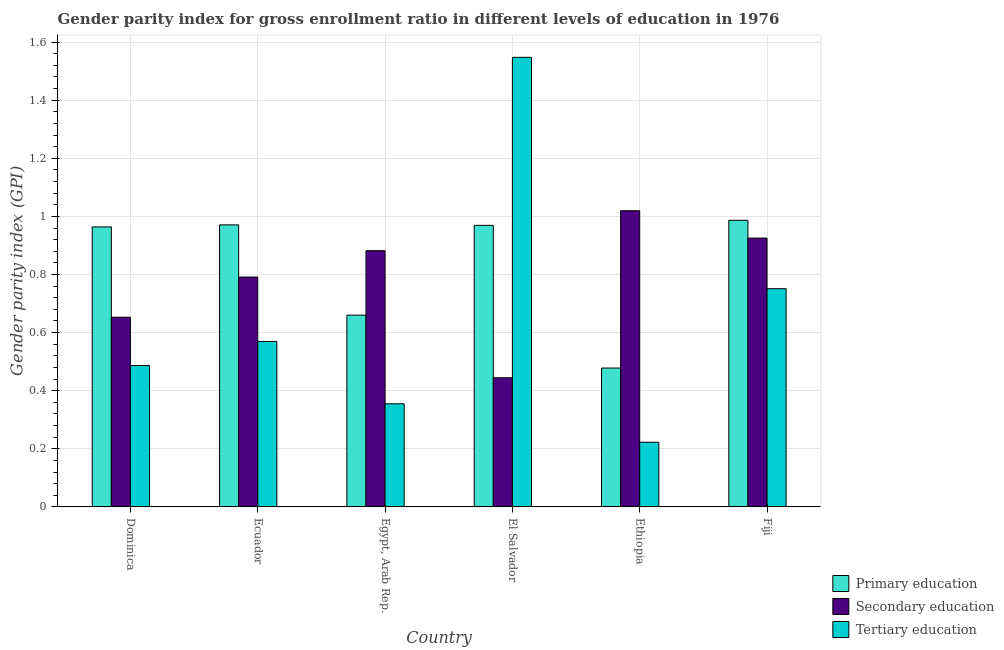How many groups of bars are there?
Ensure brevity in your answer.  6. Are the number of bars per tick equal to the number of legend labels?
Offer a very short reply. Yes. Are the number of bars on each tick of the X-axis equal?
Offer a very short reply. Yes. How many bars are there on the 2nd tick from the left?
Keep it short and to the point. 3. How many bars are there on the 5th tick from the right?
Provide a succinct answer. 3. What is the label of the 6th group of bars from the left?
Your answer should be very brief. Fiji. In how many cases, is the number of bars for a given country not equal to the number of legend labels?
Provide a short and direct response. 0. What is the gender parity index in primary education in Ethiopia?
Give a very brief answer. 0.48. Across all countries, what is the maximum gender parity index in primary education?
Ensure brevity in your answer.  0.99. Across all countries, what is the minimum gender parity index in secondary education?
Make the answer very short. 0.44. In which country was the gender parity index in tertiary education maximum?
Your answer should be very brief. El Salvador. In which country was the gender parity index in primary education minimum?
Your answer should be very brief. Ethiopia. What is the total gender parity index in tertiary education in the graph?
Give a very brief answer. 3.93. What is the difference between the gender parity index in tertiary education in Ecuador and that in El Salvador?
Ensure brevity in your answer.  -0.98. What is the difference between the gender parity index in secondary education in Egypt, Arab Rep. and the gender parity index in tertiary education in Ethiopia?
Your answer should be compact. 0.66. What is the average gender parity index in tertiary education per country?
Offer a very short reply. 0.66. What is the difference between the gender parity index in primary education and gender parity index in tertiary education in Fiji?
Offer a very short reply. 0.24. In how many countries, is the gender parity index in secondary education greater than 1.56 ?
Give a very brief answer. 0. What is the ratio of the gender parity index in secondary education in Ecuador to that in Ethiopia?
Provide a short and direct response. 0.78. What is the difference between the highest and the second highest gender parity index in primary education?
Your answer should be very brief. 0.02. What is the difference between the highest and the lowest gender parity index in primary education?
Make the answer very short. 0.51. What does the 2nd bar from the left in El Salvador represents?
Offer a very short reply. Secondary education. Is it the case that in every country, the sum of the gender parity index in primary education and gender parity index in secondary education is greater than the gender parity index in tertiary education?
Make the answer very short. No. How many bars are there?
Make the answer very short. 18. Are all the bars in the graph horizontal?
Make the answer very short. No. How many countries are there in the graph?
Provide a short and direct response. 6. Does the graph contain grids?
Give a very brief answer. Yes. Where does the legend appear in the graph?
Make the answer very short. Bottom right. How are the legend labels stacked?
Give a very brief answer. Vertical. What is the title of the graph?
Your response must be concise. Gender parity index for gross enrollment ratio in different levels of education in 1976. What is the label or title of the Y-axis?
Give a very brief answer. Gender parity index (GPI). What is the Gender parity index (GPI) of Primary education in Dominica?
Give a very brief answer. 0.96. What is the Gender parity index (GPI) of Secondary education in Dominica?
Provide a succinct answer. 0.65. What is the Gender parity index (GPI) of Tertiary education in Dominica?
Your answer should be very brief. 0.49. What is the Gender parity index (GPI) of Primary education in Ecuador?
Provide a short and direct response. 0.97. What is the Gender parity index (GPI) in Secondary education in Ecuador?
Offer a very short reply. 0.79. What is the Gender parity index (GPI) in Tertiary education in Ecuador?
Provide a succinct answer. 0.57. What is the Gender parity index (GPI) of Primary education in Egypt, Arab Rep.?
Your answer should be very brief. 0.66. What is the Gender parity index (GPI) of Secondary education in Egypt, Arab Rep.?
Give a very brief answer. 0.88. What is the Gender parity index (GPI) of Tertiary education in Egypt, Arab Rep.?
Provide a succinct answer. 0.35. What is the Gender parity index (GPI) in Primary education in El Salvador?
Your response must be concise. 0.97. What is the Gender parity index (GPI) in Secondary education in El Salvador?
Give a very brief answer. 0.44. What is the Gender parity index (GPI) of Tertiary education in El Salvador?
Make the answer very short. 1.55. What is the Gender parity index (GPI) in Primary education in Ethiopia?
Your answer should be very brief. 0.48. What is the Gender parity index (GPI) in Secondary education in Ethiopia?
Make the answer very short. 1.02. What is the Gender parity index (GPI) of Tertiary education in Ethiopia?
Ensure brevity in your answer.  0.22. What is the Gender parity index (GPI) in Primary education in Fiji?
Give a very brief answer. 0.99. What is the Gender parity index (GPI) of Secondary education in Fiji?
Keep it short and to the point. 0.93. What is the Gender parity index (GPI) of Tertiary education in Fiji?
Provide a succinct answer. 0.75. Across all countries, what is the maximum Gender parity index (GPI) of Primary education?
Your answer should be compact. 0.99. Across all countries, what is the maximum Gender parity index (GPI) of Secondary education?
Provide a short and direct response. 1.02. Across all countries, what is the maximum Gender parity index (GPI) in Tertiary education?
Your answer should be compact. 1.55. Across all countries, what is the minimum Gender parity index (GPI) of Primary education?
Your answer should be very brief. 0.48. Across all countries, what is the minimum Gender parity index (GPI) in Secondary education?
Your answer should be compact. 0.44. Across all countries, what is the minimum Gender parity index (GPI) in Tertiary education?
Provide a succinct answer. 0.22. What is the total Gender parity index (GPI) of Primary education in the graph?
Offer a terse response. 5.03. What is the total Gender parity index (GPI) of Secondary education in the graph?
Ensure brevity in your answer.  4.72. What is the total Gender parity index (GPI) of Tertiary education in the graph?
Offer a terse response. 3.93. What is the difference between the Gender parity index (GPI) in Primary education in Dominica and that in Ecuador?
Give a very brief answer. -0.01. What is the difference between the Gender parity index (GPI) of Secondary education in Dominica and that in Ecuador?
Provide a short and direct response. -0.14. What is the difference between the Gender parity index (GPI) of Tertiary education in Dominica and that in Ecuador?
Ensure brevity in your answer.  -0.08. What is the difference between the Gender parity index (GPI) of Primary education in Dominica and that in Egypt, Arab Rep.?
Your response must be concise. 0.3. What is the difference between the Gender parity index (GPI) of Secondary education in Dominica and that in Egypt, Arab Rep.?
Offer a very short reply. -0.23. What is the difference between the Gender parity index (GPI) of Tertiary education in Dominica and that in Egypt, Arab Rep.?
Your answer should be very brief. 0.13. What is the difference between the Gender parity index (GPI) of Primary education in Dominica and that in El Salvador?
Keep it short and to the point. -0.01. What is the difference between the Gender parity index (GPI) in Secondary education in Dominica and that in El Salvador?
Give a very brief answer. 0.21. What is the difference between the Gender parity index (GPI) of Tertiary education in Dominica and that in El Salvador?
Offer a terse response. -1.06. What is the difference between the Gender parity index (GPI) of Primary education in Dominica and that in Ethiopia?
Offer a very short reply. 0.49. What is the difference between the Gender parity index (GPI) in Secondary education in Dominica and that in Ethiopia?
Make the answer very short. -0.37. What is the difference between the Gender parity index (GPI) in Tertiary education in Dominica and that in Ethiopia?
Make the answer very short. 0.26. What is the difference between the Gender parity index (GPI) in Primary education in Dominica and that in Fiji?
Make the answer very short. -0.02. What is the difference between the Gender parity index (GPI) of Secondary education in Dominica and that in Fiji?
Your response must be concise. -0.27. What is the difference between the Gender parity index (GPI) in Tertiary education in Dominica and that in Fiji?
Your answer should be very brief. -0.26. What is the difference between the Gender parity index (GPI) of Primary education in Ecuador and that in Egypt, Arab Rep.?
Ensure brevity in your answer.  0.31. What is the difference between the Gender parity index (GPI) of Secondary education in Ecuador and that in Egypt, Arab Rep.?
Your response must be concise. -0.09. What is the difference between the Gender parity index (GPI) in Tertiary education in Ecuador and that in Egypt, Arab Rep.?
Give a very brief answer. 0.21. What is the difference between the Gender parity index (GPI) of Primary education in Ecuador and that in El Salvador?
Your response must be concise. 0. What is the difference between the Gender parity index (GPI) of Secondary education in Ecuador and that in El Salvador?
Give a very brief answer. 0.35. What is the difference between the Gender parity index (GPI) in Tertiary education in Ecuador and that in El Salvador?
Your response must be concise. -0.98. What is the difference between the Gender parity index (GPI) in Primary education in Ecuador and that in Ethiopia?
Provide a short and direct response. 0.49. What is the difference between the Gender parity index (GPI) in Secondary education in Ecuador and that in Ethiopia?
Ensure brevity in your answer.  -0.23. What is the difference between the Gender parity index (GPI) in Tertiary education in Ecuador and that in Ethiopia?
Offer a very short reply. 0.35. What is the difference between the Gender parity index (GPI) in Primary education in Ecuador and that in Fiji?
Your response must be concise. -0.02. What is the difference between the Gender parity index (GPI) in Secondary education in Ecuador and that in Fiji?
Ensure brevity in your answer.  -0.13. What is the difference between the Gender parity index (GPI) in Tertiary education in Ecuador and that in Fiji?
Ensure brevity in your answer.  -0.18. What is the difference between the Gender parity index (GPI) of Primary education in Egypt, Arab Rep. and that in El Salvador?
Give a very brief answer. -0.31. What is the difference between the Gender parity index (GPI) in Secondary education in Egypt, Arab Rep. and that in El Salvador?
Make the answer very short. 0.44. What is the difference between the Gender parity index (GPI) of Tertiary education in Egypt, Arab Rep. and that in El Salvador?
Give a very brief answer. -1.19. What is the difference between the Gender parity index (GPI) of Primary education in Egypt, Arab Rep. and that in Ethiopia?
Your response must be concise. 0.18. What is the difference between the Gender parity index (GPI) of Secondary education in Egypt, Arab Rep. and that in Ethiopia?
Your answer should be very brief. -0.14. What is the difference between the Gender parity index (GPI) of Tertiary education in Egypt, Arab Rep. and that in Ethiopia?
Give a very brief answer. 0.13. What is the difference between the Gender parity index (GPI) in Primary education in Egypt, Arab Rep. and that in Fiji?
Your answer should be very brief. -0.33. What is the difference between the Gender parity index (GPI) of Secondary education in Egypt, Arab Rep. and that in Fiji?
Your answer should be compact. -0.04. What is the difference between the Gender parity index (GPI) of Tertiary education in Egypt, Arab Rep. and that in Fiji?
Provide a succinct answer. -0.4. What is the difference between the Gender parity index (GPI) in Primary education in El Salvador and that in Ethiopia?
Offer a very short reply. 0.49. What is the difference between the Gender parity index (GPI) in Secondary education in El Salvador and that in Ethiopia?
Provide a succinct answer. -0.57. What is the difference between the Gender parity index (GPI) of Tertiary education in El Salvador and that in Ethiopia?
Provide a succinct answer. 1.32. What is the difference between the Gender parity index (GPI) in Primary education in El Salvador and that in Fiji?
Provide a succinct answer. -0.02. What is the difference between the Gender parity index (GPI) of Secondary education in El Salvador and that in Fiji?
Provide a succinct answer. -0.48. What is the difference between the Gender parity index (GPI) of Tertiary education in El Salvador and that in Fiji?
Provide a succinct answer. 0.8. What is the difference between the Gender parity index (GPI) in Primary education in Ethiopia and that in Fiji?
Your response must be concise. -0.51. What is the difference between the Gender parity index (GPI) of Secondary education in Ethiopia and that in Fiji?
Keep it short and to the point. 0.09. What is the difference between the Gender parity index (GPI) in Tertiary education in Ethiopia and that in Fiji?
Offer a terse response. -0.53. What is the difference between the Gender parity index (GPI) in Primary education in Dominica and the Gender parity index (GPI) in Secondary education in Ecuador?
Make the answer very short. 0.17. What is the difference between the Gender parity index (GPI) in Primary education in Dominica and the Gender parity index (GPI) in Tertiary education in Ecuador?
Offer a very short reply. 0.39. What is the difference between the Gender parity index (GPI) of Secondary education in Dominica and the Gender parity index (GPI) of Tertiary education in Ecuador?
Provide a short and direct response. 0.08. What is the difference between the Gender parity index (GPI) in Primary education in Dominica and the Gender parity index (GPI) in Secondary education in Egypt, Arab Rep.?
Your response must be concise. 0.08. What is the difference between the Gender parity index (GPI) in Primary education in Dominica and the Gender parity index (GPI) in Tertiary education in Egypt, Arab Rep.?
Your answer should be compact. 0.61. What is the difference between the Gender parity index (GPI) in Secondary education in Dominica and the Gender parity index (GPI) in Tertiary education in Egypt, Arab Rep.?
Give a very brief answer. 0.3. What is the difference between the Gender parity index (GPI) in Primary education in Dominica and the Gender parity index (GPI) in Secondary education in El Salvador?
Offer a very short reply. 0.52. What is the difference between the Gender parity index (GPI) of Primary education in Dominica and the Gender parity index (GPI) of Tertiary education in El Salvador?
Provide a short and direct response. -0.58. What is the difference between the Gender parity index (GPI) in Secondary education in Dominica and the Gender parity index (GPI) in Tertiary education in El Salvador?
Make the answer very short. -0.89. What is the difference between the Gender parity index (GPI) of Primary education in Dominica and the Gender parity index (GPI) of Secondary education in Ethiopia?
Your answer should be very brief. -0.06. What is the difference between the Gender parity index (GPI) in Primary education in Dominica and the Gender parity index (GPI) in Tertiary education in Ethiopia?
Offer a terse response. 0.74. What is the difference between the Gender parity index (GPI) in Secondary education in Dominica and the Gender parity index (GPI) in Tertiary education in Ethiopia?
Your answer should be compact. 0.43. What is the difference between the Gender parity index (GPI) of Primary education in Dominica and the Gender parity index (GPI) of Secondary education in Fiji?
Your answer should be very brief. 0.04. What is the difference between the Gender parity index (GPI) in Primary education in Dominica and the Gender parity index (GPI) in Tertiary education in Fiji?
Your answer should be very brief. 0.21. What is the difference between the Gender parity index (GPI) in Secondary education in Dominica and the Gender parity index (GPI) in Tertiary education in Fiji?
Your answer should be compact. -0.1. What is the difference between the Gender parity index (GPI) in Primary education in Ecuador and the Gender parity index (GPI) in Secondary education in Egypt, Arab Rep.?
Provide a succinct answer. 0.09. What is the difference between the Gender parity index (GPI) in Primary education in Ecuador and the Gender parity index (GPI) in Tertiary education in Egypt, Arab Rep.?
Your answer should be very brief. 0.62. What is the difference between the Gender parity index (GPI) in Secondary education in Ecuador and the Gender parity index (GPI) in Tertiary education in Egypt, Arab Rep.?
Offer a terse response. 0.44. What is the difference between the Gender parity index (GPI) of Primary education in Ecuador and the Gender parity index (GPI) of Secondary education in El Salvador?
Your response must be concise. 0.53. What is the difference between the Gender parity index (GPI) in Primary education in Ecuador and the Gender parity index (GPI) in Tertiary education in El Salvador?
Keep it short and to the point. -0.58. What is the difference between the Gender parity index (GPI) in Secondary education in Ecuador and the Gender parity index (GPI) in Tertiary education in El Salvador?
Your answer should be compact. -0.76. What is the difference between the Gender parity index (GPI) of Primary education in Ecuador and the Gender parity index (GPI) of Secondary education in Ethiopia?
Keep it short and to the point. -0.05. What is the difference between the Gender parity index (GPI) in Primary education in Ecuador and the Gender parity index (GPI) in Tertiary education in Ethiopia?
Keep it short and to the point. 0.75. What is the difference between the Gender parity index (GPI) in Secondary education in Ecuador and the Gender parity index (GPI) in Tertiary education in Ethiopia?
Give a very brief answer. 0.57. What is the difference between the Gender parity index (GPI) of Primary education in Ecuador and the Gender parity index (GPI) of Secondary education in Fiji?
Provide a short and direct response. 0.05. What is the difference between the Gender parity index (GPI) in Primary education in Ecuador and the Gender parity index (GPI) in Tertiary education in Fiji?
Your answer should be very brief. 0.22. What is the difference between the Gender parity index (GPI) of Secondary education in Ecuador and the Gender parity index (GPI) of Tertiary education in Fiji?
Your answer should be compact. 0.04. What is the difference between the Gender parity index (GPI) of Primary education in Egypt, Arab Rep. and the Gender parity index (GPI) of Secondary education in El Salvador?
Provide a short and direct response. 0.22. What is the difference between the Gender parity index (GPI) in Primary education in Egypt, Arab Rep. and the Gender parity index (GPI) in Tertiary education in El Salvador?
Your answer should be compact. -0.89. What is the difference between the Gender parity index (GPI) in Secondary education in Egypt, Arab Rep. and the Gender parity index (GPI) in Tertiary education in El Salvador?
Ensure brevity in your answer.  -0.67. What is the difference between the Gender parity index (GPI) of Primary education in Egypt, Arab Rep. and the Gender parity index (GPI) of Secondary education in Ethiopia?
Make the answer very short. -0.36. What is the difference between the Gender parity index (GPI) of Primary education in Egypt, Arab Rep. and the Gender parity index (GPI) of Tertiary education in Ethiopia?
Provide a short and direct response. 0.44. What is the difference between the Gender parity index (GPI) in Secondary education in Egypt, Arab Rep. and the Gender parity index (GPI) in Tertiary education in Ethiopia?
Keep it short and to the point. 0.66. What is the difference between the Gender parity index (GPI) in Primary education in Egypt, Arab Rep. and the Gender parity index (GPI) in Secondary education in Fiji?
Make the answer very short. -0.27. What is the difference between the Gender parity index (GPI) in Primary education in Egypt, Arab Rep. and the Gender parity index (GPI) in Tertiary education in Fiji?
Your answer should be compact. -0.09. What is the difference between the Gender parity index (GPI) in Secondary education in Egypt, Arab Rep. and the Gender parity index (GPI) in Tertiary education in Fiji?
Give a very brief answer. 0.13. What is the difference between the Gender parity index (GPI) in Primary education in El Salvador and the Gender parity index (GPI) in Secondary education in Ethiopia?
Offer a very short reply. -0.05. What is the difference between the Gender parity index (GPI) in Primary education in El Salvador and the Gender parity index (GPI) in Tertiary education in Ethiopia?
Keep it short and to the point. 0.75. What is the difference between the Gender parity index (GPI) of Secondary education in El Salvador and the Gender parity index (GPI) of Tertiary education in Ethiopia?
Your answer should be very brief. 0.22. What is the difference between the Gender parity index (GPI) in Primary education in El Salvador and the Gender parity index (GPI) in Secondary education in Fiji?
Your response must be concise. 0.04. What is the difference between the Gender parity index (GPI) in Primary education in El Salvador and the Gender parity index (GPI) in Tertiary education in Fiji?
Make the answer very short. 0.22. What is the difference between the Gender parity index (GPI) of Secondary education in El Salvador and the Gender parity index (GPI) of Tertiary education in Fiji?
Provide a short and direct response. -0.31. What is the difference between the Gender parity index (GPI) in Primary education in Ethiopia and the Gender parity index (GPI) in Secondary education in Fiji?
Ensure brevity in your answer.  -0.45. What is the difference between the Gender parity index (GPI) of Primary education in Ethiopia and the Gender parity index (GPI) of Tertiary education in Fiji?
Provide a succinct answer. -0.27. What is the difference between the Gender parity index (GPI) of Secondary education in Ethiopia and the Gender parity index (GPI) of Tertiary education in Fiji?
Offer a very short reply. 0.27. What is the average Gender parity index (GPI) of Primary education per country?
Your answer should be very brief. 0.84. What is the average Gender parity index (GPI) in Secondary education per country?
Your response must be concise. 0.79. What is the average Gender parity index (GPI) of Tertiary education per country?
Ensure brevity in your answer.  0.66. What is the difference between the Gender parity index (GPI) of Primary education and Gender parity index (GPI) of Secondary education in Dominica?
Offer a very short reply. 0.31. What is the difference between the Gender parity index (GPI) of Primary education and Gender parity index (GPI) of Tertiary education in Dominica?
Your answer should be compact. 0.48. What is the difference between the Gender parity index (GPI) in Secondary education and Gender parity index (GPI) in Tertiary education in Dominica?
Your answer should be very brief. 0.17. What is the difference between the Gender parity index (GPI) of Primary education and Gender parity index (GPI) of Secondary education in Ecuador?
Give a very brief answer. 0.18. What is the difference between the Gender parity index (GPI) in Primary education and Gender parity index (GPI) in Tertiary education in Ecuador?
Provide a short and direct response. 0.4. What is the difference between the Gender parity index (GPI) in Secondary education and Gender parity index (GPI) in Tertiary education in Ecuador?
Your response must be concise. 0.22. What is the difference between the Gender parity index (GPI) in Primary education and Gender parity index (GPI) in Secondary education in Egypt, Arab Rep.?
Your answer should be very brief. -0.22. What is the difference between the Gender parity index (GPI) of Primary education and Gender parity index (GPI) of Tertiary education in Egypt, Arab Rep.?
Give a very brief answer. 0.31. What is the difference between the Gender parity index (GPI) in Secondary education and Gender parity index (GPI) in Tertiary education in Egypt, Arab Rep.?
Provide a succinct answer. 0.53. What is the difference between the Gender parity index (GPI) in Primary education and Gender parity index (GPI) in Secondary education in El Salvador?
Offer a very short reply. 0.52. What is the difference between the Gender parity index (GPI) in Primary education and Gender parity index (GPI) in Tertiary education in El Salvador?
Your answer should be very brief. -0.58. What is the difference between the Gender parity index (GPI) of Secondary education and Gender parity index (GPI) of Tertiary education in El Salvador?
Your response must be concise. -1.1. What is the difference between the Gender parity index (GPI) of Primary education and Gender parity index (GPI) of Secondary education in Ethiopia?
Your response must be concise. -0.54. What is the difference between the Gender parity index (GPI) of Primary education and Gender parity index (GPI) of Tertiary education in Ethiopia?
Make the answer very short. 0.26. What is the difference between the Gender parity index (GPI) of Secondary education and Gender parity index (GPI) of Tertiary education in Ethiopia?
Make the answer very short. 0.8. What is the difference between the Gender parity index (GPI) in Primary education and Gender parity index (GPI) in Secondary education in Fiji?
Your answer should be very brief. 0.06. What is the difference between the Gender parity index (GPI) in Primary education and Gender parity index (GPI) in Tertiary education in Fiji?
Provide a short and direct response. 0.24. What is the difference between the Gender parity index (GPI) of Secondary education and Gender parity index (GPI) of Tertiary education in Fiji?
Keep it short and to the point. 0.17. What is the ratio of the Gender parity index (GPI) in Primary education in Dominica to that in Ecuador?
Keep it short and to the point. 0.99. What is the ratio of the Gender parity index (GPI) in Secondary education in Dominica to that in Ecuador?
Provide a short and direct response. 0.83. What is the ratio of the Gender parity index (GPI) of Tertiary education in Dominica to that in Ecuador?
Your answer should be compact. 0.85. What is the ratio of the Gender parity index (GPI) in Primary education in Dominica to that in Egypt, Arab Rep.?
Your response must be concise. 1.46. What is the ratio of the Gender parity index (GPI) in Secondary education in Dominica to that in Egypt, Arab Rep.?
Offer a very short reply. 0.74. What is the ratio of the Gender parity index (GPI) in Tertiary education in Dominica to that in Egypt, Arab Rep.?
Your response must be concise. 1.37. What is the ratio of the Gender parity index (GPI) of Secondary education in Dominica to that in El Salvador?
Make the answer very short. 1.47. What is the ratio of the Gender parity index (GPI) in Tertiary education in Dominica to that in El Salvador?
Ensure brevity in your answer.  0.31. What is the ratio of the Gender parity index (GPI) in Primary education in Dominica to that in Ethiopia?
Your answer should be compact. 2.02. What is the ratio of the Gender parity index (GPI) in Secondary education in Dominica to that in Ethiopia?
Your answer should be compact. 0.64. What is the ratio of the Gender parity index (GPI) in Tertiary education in Dominica to that in Ethiopia?
Your answer should be very brief. 2.19. What is the ratio of the Gender parity index (GPI) of Secondary education in Dominica to that in Fiji?
Your answer should be compact. 0.71. What is the ratio of the Gender parity index (GPI) of Tertiary education in Dominica to that in Fiji?
Give a very brief answer. 0.65. What is the ratio of the Gender parity index (GPI) of Primary education in Ecuador to that in Egypt, Arab Rep.?
Offer a terse response. 1.47. What is the ratio of the Gender parity index (GPI) of Secondary education in Ecuador to that in Egypt, Arab Rep.?
Provide a succinct answer. 0.9. What is the ratio of the Gender parity index (GPI) of Tertiary education in Ecuador to that in Egypt, Arab Rep.?
Your answer should be compact. 1.6. What is the ratio of the Gender parity index (GPI) of Secondary education in Ecuador to that in El Salvador?
Give a very brief answer. 1.78. What is the ratio of the Gender parity index (GPI) in Tertiary education in Ecuador to that in El Salvador?
Offer a terse response. 0.37. What is the ratio of the Gender parity index (GPI) of Primary education in Ecuador to that in Ethiopia?
Keep it short and to the point. 2.03. What is the ratio of the Gender parity index (GPI) in Secondary education in Ecuador to that in Ethiopia?
Ensure brevity in your answer.  0.78. What is the ratio of the Gender parity index (GPI) in Tertiary education in Ecuador to that in Ethiopia?
Your answer should be compact. 2.56. What is the ratio of the Gender parity index (GPI) in Primary education in Ecuador to that in Fiji?
Offer a terse response. 0.98. What is the ratio of the Gender parity index (GPI) in Secondary education in Ecuador to that in Fiji?
Provide a succinct answer. 0.86. What is the ratio of the Gender parity index (GPI) of Tertiary education in Ecuador to that in Fiji?
Provide a short and direct response. 0.76. What is the ratio of the Gender parity index (GPI) of Primary education in Egypt, Arab Rep. to that in El Salvador?
Your answer should be very brief. 0.68. What is the ratio of the Gender parity index (GPI) in Secondary education in Egypt, Arab Rep. to that in El Salvador?
Your response must be concise. 1.98. What is the ratio of the Gender parity index (GPI) of Tertiary education in Egypt, Arab Rep. to that in El Salvador?
Offer a very short reply. 0.23. What is the ratio of the Gender parity index (GPI) in Primary education in Egypt, Arab Rep. to that in Ethiopia?
Make the answer very short. 1.38. What is the ratio of the Gender parity index (GPI) of Secondary education in Egypt, Arab Rep. to that in Ethiopia?
Provide a short and direct response. 0.86. What is the ratio of the Gender parity index (GPI) of Tertiary education in Egypt, Arab Rep. to that in Ethiopia?
Provide a short and direct response. 1.59. What is the ratio of the Gender parity index (GPI) of Primary education in Egypt, Arab Rep. to that in Fiji?
Keep it short and to the point. 0.67. What is the ratio of the Gender parity index (GPI) of Secondary education in Egypt, Arab Rep. to that in Fiji?
Ensure brevity in your answer.  0.95. What is the ratio of the Gender parity index (GPI) in Tertiary education in Egypt, Arab Rep. to that in Fiji?
Offer a terse response. 0.47. What is the ratio of the Gender parity index (GPI) of Primary education in El Salvador to that in Ethiopia?
Ensure brevity in your answer.  2.03. What is the ratio of the Gender parity index (GPI) of Secondary education in El Salvador to that in Ethiopia?
Your answer should be compact. 0.44. What is the ratio of the Gender parity index (GPI) of Tertiary education in El Salvador to that in Ethiopia?
Provide a succinct answer. 6.95. What is the ratio of the Gender parity index (GPI) of Primary education in El Salvador to that in Fiji?
Offer a very short reply. 0.98. What is the ratio of the Gender parity index (GPI) in Secondary education in El Salvador to that in Fiji?
Your answer should be compact. 0.48. What is the ratio of the Gender parity index (GPI) of Tertiary education in El Salvador to that in Fiji?
Provide a succinct answer. 2.06. What is the ratio of the Gender parity index (GPI) of Primary education in Ethiopia to that in Fiji?
Your response must be concise. 0.48. What is the ratio of the Gender parity index (GPI) in Secondary education in Ethiopia to that in Fiji?
Make the answer very short. 1.1. What is the ratio of the Gender parity index (GPI) in Tertiary education in Ethiopia to that in Fiji?
Give a very brief answer. 0.3. What is the difference between the highest and the second highest Gender parity index (GPI) of Primary education?
Give a very brief answer. 0.02. What is the difference between the highest and the second highest Gender parity index (GPI) in Secondary education?
Provide a succinct answer. 0.09. What is the difference between the highest and the second highest Gender parity index (GPI) in Tertiary education?
Your answer should be very brief. 0.8. What is the difference between the highest and the lowest Gender parity index (GPI) of Primary education?
Your answer should be compact. 0.51. What is the difference between the highest and the lowest Gender parity index (GPI) of Secondary education?
Make the answer very short. 0.57. What is the difference between the highest and the lowest Gender parity index (GPI) of Tertiary education?
Give a very brief answer. 1.32. 